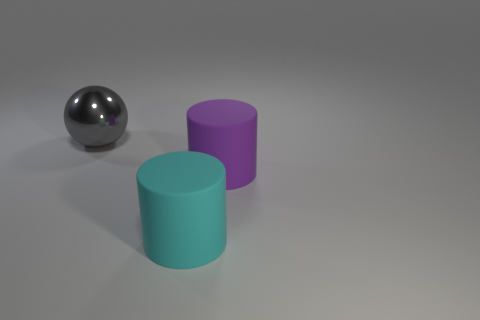Is the color of the cylinder in front of the large purple thing the same as the big sphere?
Offer a terse response. No. How many tiny things are either blue matte things or purple cylinders?
Give a very brief answer. 0. There is a big thing behind the purple cylinder; what shape is it?
Offer a very short reply. Sphere. What number of large green shiny cylinders are there?
Provide a succinct answer. 0. Is the purple thing made of the same material as the large cyan thing?
Your answer should be very brief. Yes. Are there more shiny things that are to the left of the large cyan object than purple metal cubes?
Your answer should be very brief. Yes. What number of things are either cyan rubber cylinders or objects behind the large cyan matte cylinder?
Keep it short and to the point. 3. Is the number of purple rubber things that are behind the cyan rubber object greater than the number of cylinders on the right side of the big purple matte object?
Offer a very short reply. Yes. There is a large cylinder behind the rubber thing that is left of the big matte cylinder on the right side of the large cyan matte thing; what is its material?
Offer a terse response. Rubber. There is a purple thing that is made of the same material as the big cyan cylinder; what shape is it?
Ensure brevity in your answer.  Cylinder. 